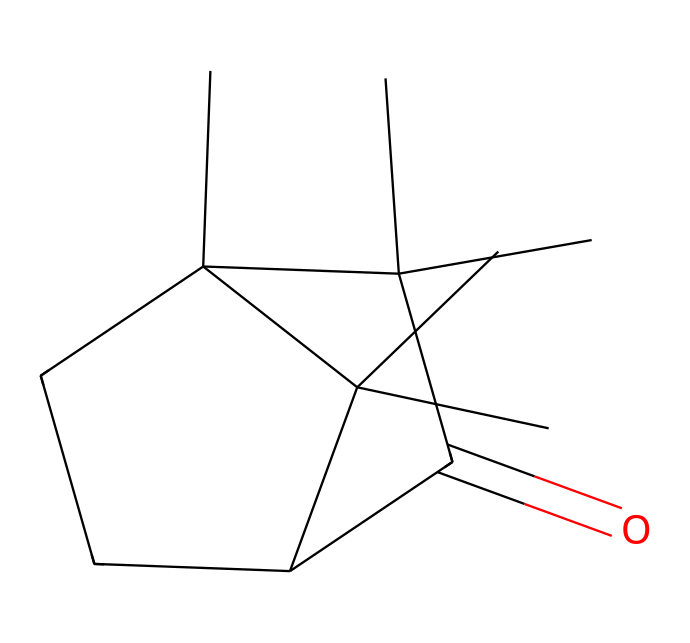how many carbon atoms are in the molecular structure of camphor? In the provided SMILES representation, we can count the number of carbon (C) atoms that are present. There are a total of 15 carbon atoms in the structure.
Answer: 15 how many rings are present in the structure of camphor? By analyzing the structure, we observe that there are two carbon cycles or rings formed. One ring is indicated by the “C1” and “C2”. Therefore, there are 2 rings in the structure.
Answer: 2 what functional groups are present in camphor? The structure reveals that camphor has a carbonyl (C=O) functional group, indicated by the “C(=O)” part of the SMILES. This identifies the presence of a ketone functional group in camphor.
Answer: ketone what is the molecular formula of camphor? To deduce the molecular formula, we can derive it from the composition in the SMILES. There are 15 carbon atoms, 26 hydrogen atoms, and 1 oxygen atom. Thus, the molecular formula for camphor is C15H26O.
Answer: C15H26O is camphor a cyclic compound? Yes, based on the presence of multiple rings in its structure, camphor is classified as a cyclic compound. The rings formed help define the unique molecular shape of camphor.
Answer: yes how does the presence of the carbonyl group influence camphor's properties? The carbonyl group (C=O) affects camphor's properties by increasing its polarity, which can enhance its solubility in polar solvents and may affect its reactivity and medicinal properties.
Answer: increases polarity 